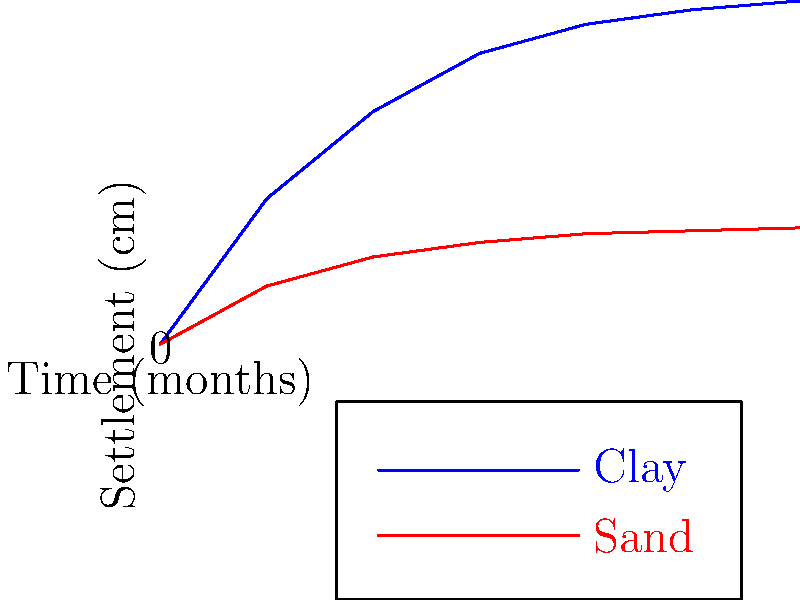Based on the soil settlement graph, calculate the difference in settlement rates between clay and sand soils during the first month. How might this difference impact the long-term stability of structures built on these soil types? To solve this problem, we need to follow these steps:

1. Identify the settlement values for clay and sand at 0 and 1 month:
   Clay: 0 cm at 0 months, 0.5 cm at 1 month
   Sand: 0 cm at 0 months, 0.2 cm at 1 month

2. Calculate the settlement rate for each soil type:
   Clay rate = (0.5 cm - 0 cm) / (1 month - 0 month) = 0.5 cm/month
   Sand rate = (0.2 cm - 0 cm) / (1 month - 0 month) = 0.2 cm/month

3. Calculate the difference in settlement rates:
   Difference = Clay rate - Sand rate = 0.5 cm/month - 0.2 cm/month = 0.3 cm/month

4. Analyze the long-term impact:
   The clay soil settles more rapidly than sand, with a difference of 0.3 cm/month in the first month. This higher initial settlement rate in clay continues over time, as seen in the graph.

   Long-term impacts:
   a) Differential settlement: Structures built on mixed soil types may experience uneven settlement, leading to structural stress.
   b) Time-dependent deformation: Clay's continued settlement over time may require more frequent maintenance and monitoring of structures.
   c) Foundation design: Different foundation types or sizes may be needed for clay vs. sand to accommodate the varying settlement rates.
   d) Drainage concerns: Clay's slower drainage may lead to increased pore water pressure, affecting soil strength and stability.

5. Conclusion:
   The 0.3 cm/month difference in initial settlement rates between clay and sand significantly impacts long-term structural stability, necessitating careful consideration in geotechnical design and construction practices.
Answer: 0.3 cm/month; higher clay settlement rate requires specialized foundation design and long-term monitoring. 